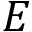Convert formula to latex. <formula><loc_0><loc_0><loc_500><loc_500>E</formula> 